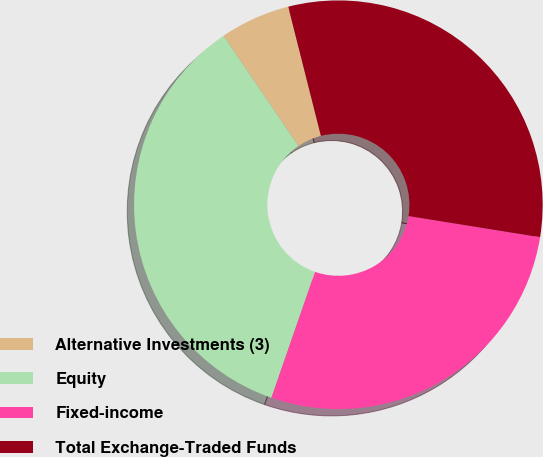Convert chart. <chart><loc_0><loc_0><loc_500><loc_500><pie_chart><fcel>Alternative Investments (3)<fcel>Equity<fcel>Fixed-income<fcel>Total Exchange-Traded Funds<nl><fcel>5.56%<fcel>35.19%<fcel>27.78%<fcel>31.48%<nl></chart> 